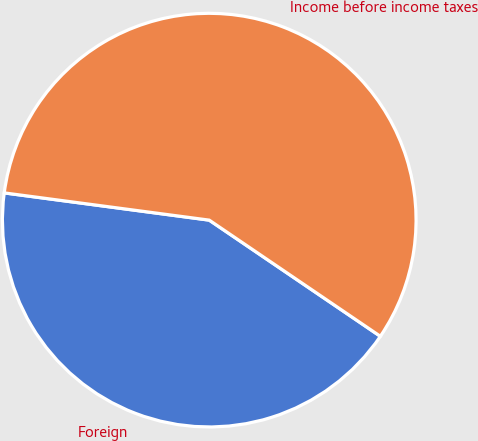Convert chart. <chart><loc_0><loc_0><loc_500><loc_500><pie_chart><fcel>Foreign<fcel>Income before income taxes<nl><fcel>42.61%<fcel>57.39%<nl></chart> 